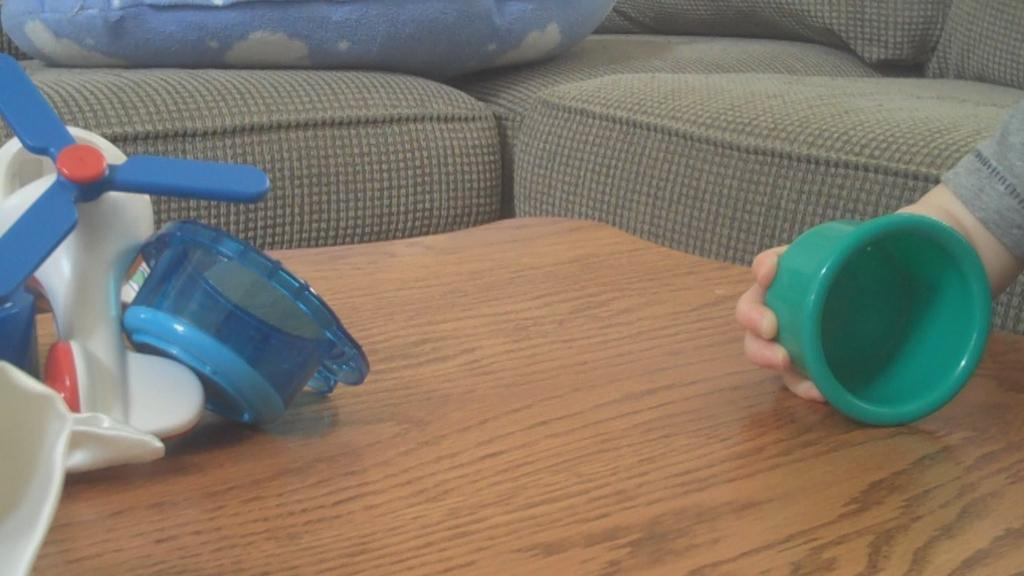What is the kid holding in the image? There is a kid's hand holding a toy in the image. Where are the toys located in the image? The toys are placed on a table in the image. What can be seen in the background of the image? There is a sofa and a cushion in the background of the image. What type of lettuce is being used as a cushion on the sofa in the image? There is no lettuce present in the image; the cushion is not made of lettuce. 